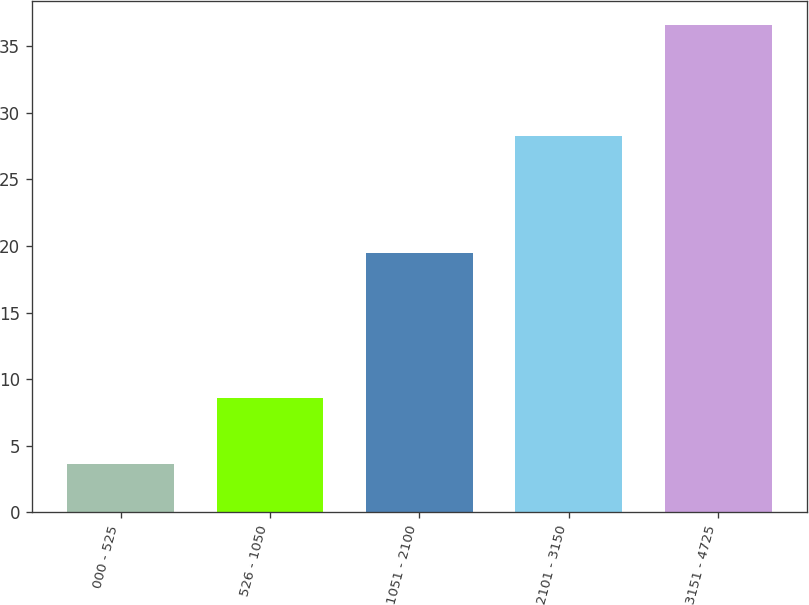<chart> <loc_0><loc_0><loc_500><loc_500><bar_chart><fcel>000 - 525<fcel>526 - 1050<fcel>1051 - 2100<fcel>2101 - 3150<fcel>3151 - 4725<nl><fcel>3.61<fcel>8.54<fcel>19.44<fcel>28.25<fcel>36.61<nl></chart> 